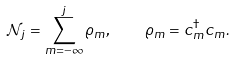<formula> <loc_0><loc_0><loc_500><loc_500>\mathcal { N } _ { j } = \sum _ { m = - \infty } ^ { j } \varrho _ { m } , \quad \varrho _ { m } = c ^ { \dagger } _ { m } c _ { m } .</formula> 